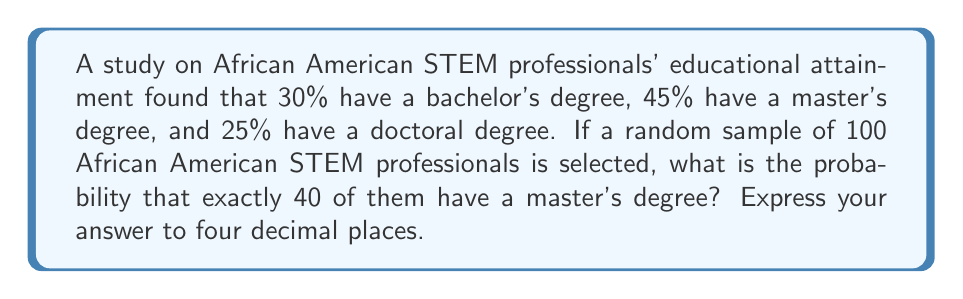Help me with this question. To solve this problem, we need to use the binomial probability distribution, as we are dealing with a fixed number of independent trials (selecting 100 professionals) with a constant probability of success (having a master's degree).

The binomial probability formula is:

$$P(X = k) = \binom{n}{k} p^k (1-p)^{n-k}$$

Where:
$n$ = number of trials (100 in this case)
$k$ = number of successes (40 in this case)
$p$ = probability of success on each trial (0.45 for master's degree)

Let's calculate step by step:

1) First, we need to calculate the binomial coefficient:

   $$\binom{100}{40} = \frac{100!}{40!(100-40)!} = \frac{100!}{40!60!}$$

2) Now, let's plug all values into the formula:

   $$P(X = 40) = \binom{100}{40} (0.45)^{40} (1-0.45)^{100-40}$$

3) Simplify:

   $$P(X = 40) = \binom{100}{40} (0.45)^{40} (0.55)^{60}$$

4) Calculate using a calculator or computer (due to the large numbers involved):

   $$P(X = 40) \approx 0.0805$$

5) Rounding to four decimal places:

   $$P(X = 40) \approx 0.0805$$
Answer: 0.0805 